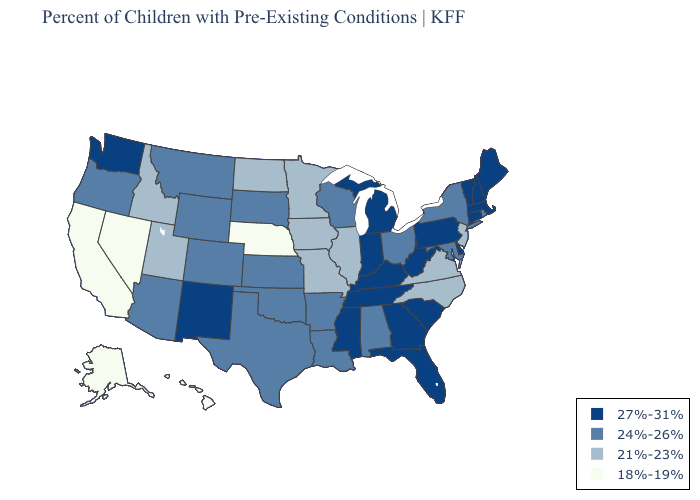What is the highest value in the USA?
Concise answer only. 27%-31%. What is the lowest value in the USA?
Quick response, please. 18%-19%. What is the lowest value in states that border Louisiana?
Answer briefly. 24%-26%. Does Iowa have a lower value than New York?
Quick response, please. Yes. Does California have the lowest value in the USA?
Quick response, please. Yes. What is the highest value in the USA?
Give a very brief answer. 27%-31%. Name the states that have a value in the range 24%-26%?
Short answer required. Alabama, Arizona, Arkansas, Colorado, Kansas, Louisiana, Maryland, Montana, New York, Ohio, Oklahoma, Oregon, Rhode Island, South Dakota, Texas, Wisconsin, Wyoming. What is the lowest value in the Northeast?
Be succinct. 21%-23%. Name the states that have a value in the range 27%-31%?
Answer briefly. Connecticut, Delaware, Florida, Georgia, Indiana, Kentucky, Maine, Massachusetts, Michigan, Mississippi, New Hampshire, New Mexico, Pennsylvania, South Carolina, Tennessee, Vermont, Washington, West Virginia. Does Nevada have a higher value than Texas?
Write a very short answer. No. Does the map have missing data?
Be succinct. No. What is the highest value in states that border Oklahoma?
Quick response, please. 27%-31%. What is the value of South Carolina?
Concise answer only. 27%-31%. Does Nebraska have the lowest value in the MidWest?
Write a very short answer. Yes. Does Nebraska have the lowest value in the USA?
Short answer required. Yes. 